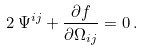<formula> <loc_0><loc_0><loc_500><loc_500>2 \, \Psi ^ { i j } + \frac { \partial f } { \partial \Omega _ { i j } } = 0 \, .</formula> 